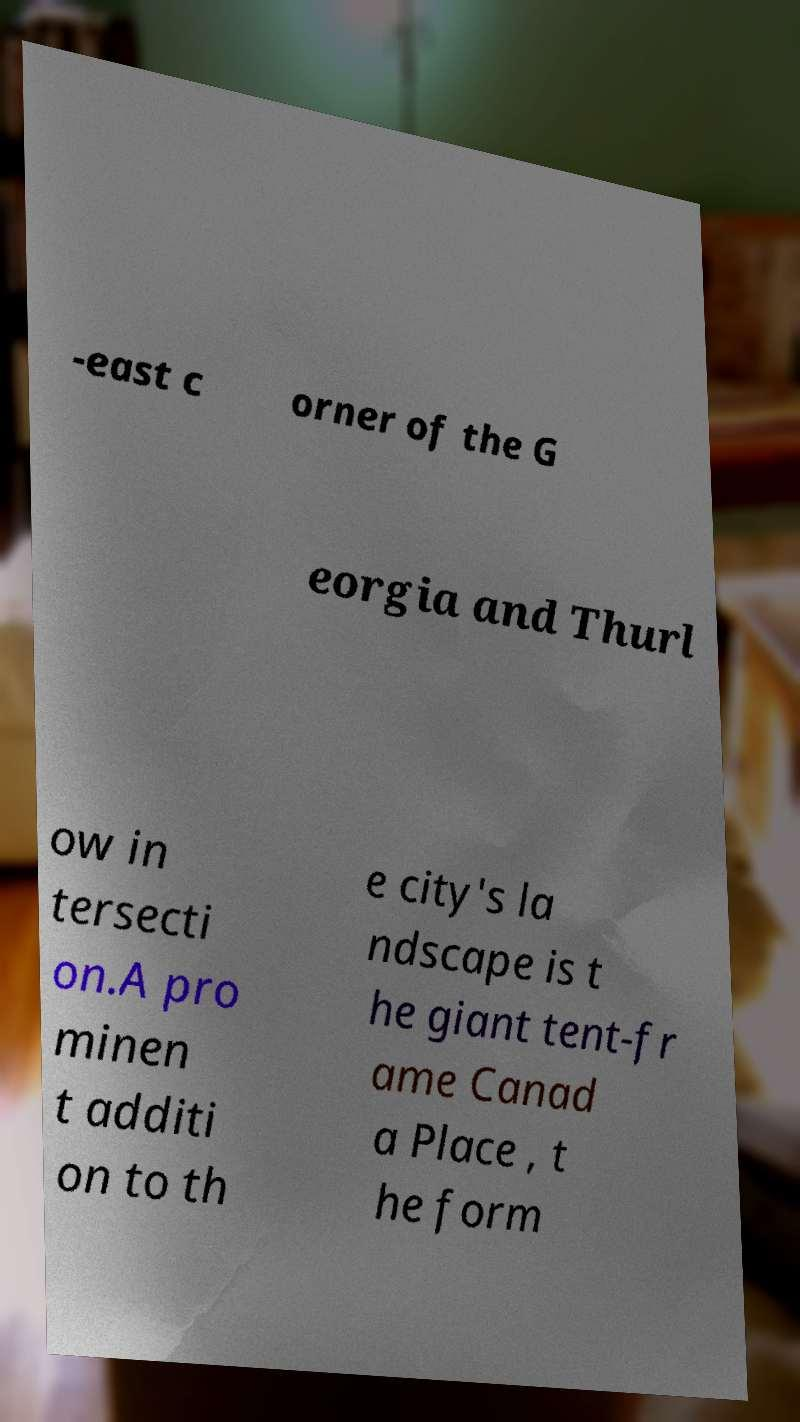I need the written content from this picture converted into text. Can you do that? -east c orner of the G eorgia and Thurl ow in tersecti on.A pro minen t additi on to th e city's la ndscape is t he giant tent-fr ame Canad a Place , t he form 